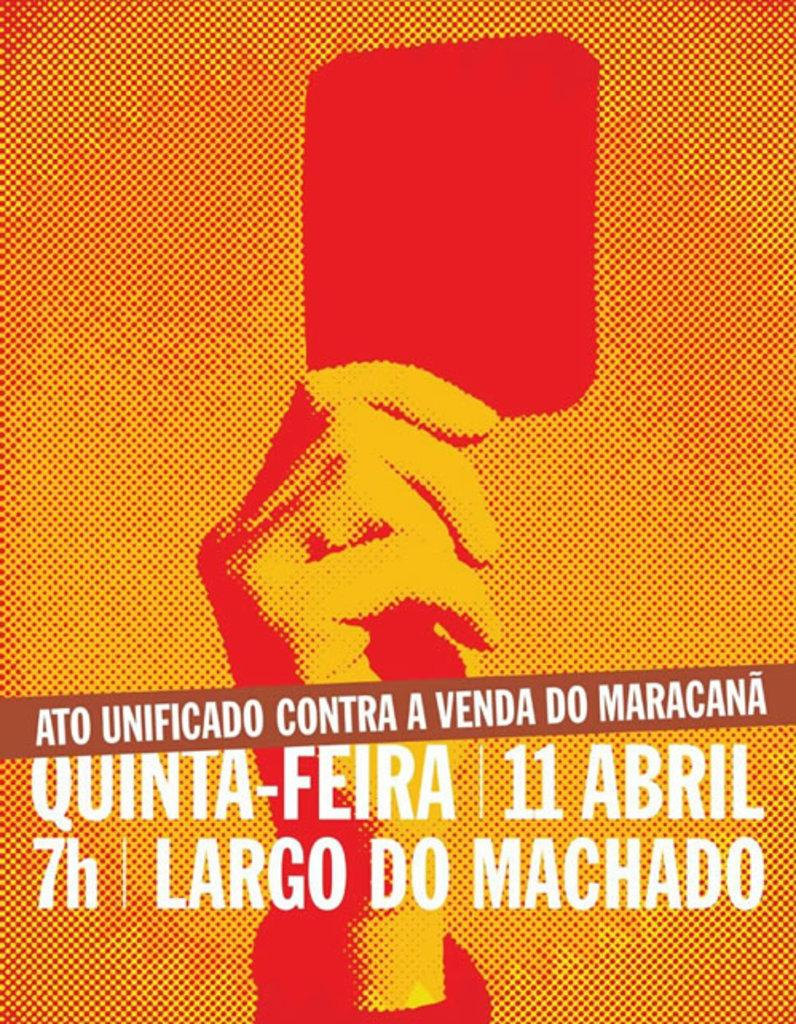Provide a one-sentence caption for the provided image. A poster of a man raising a red card announcing an event on the 11 of April at 7. 